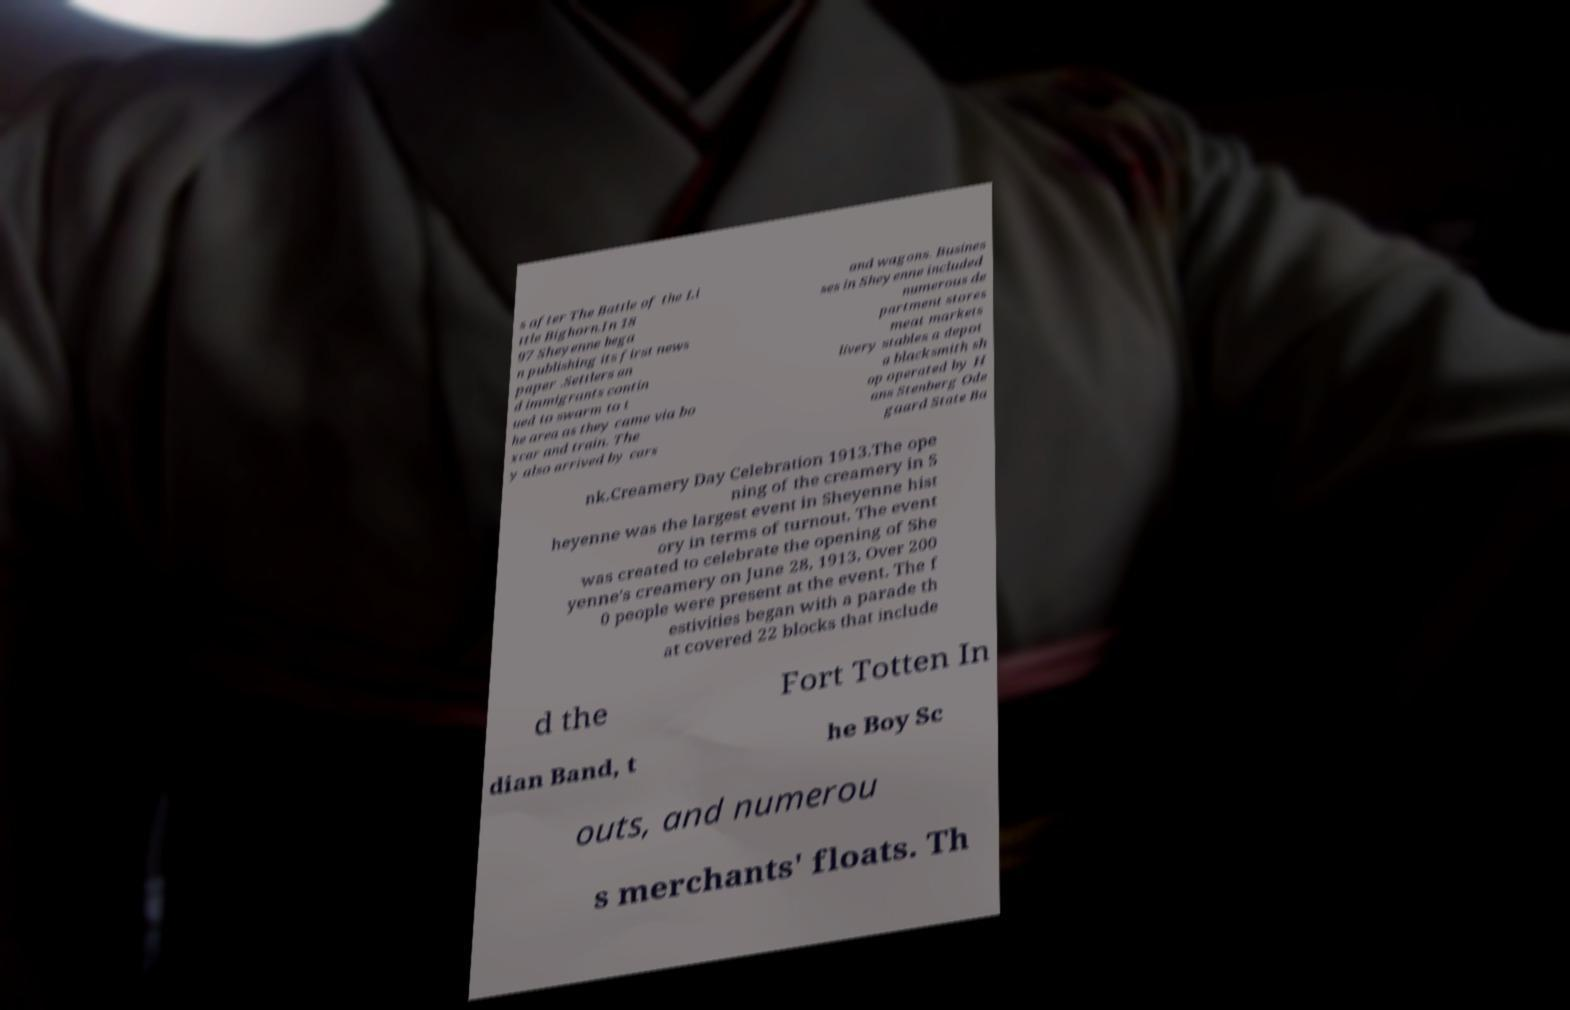Could you assist in decoding the text presented in this image and type it out clearly? s after The Battle of the Li ttle Bighorn.In 18 97 Sheyenne bega n publishing its first news paper .Settlers an d immigrants contin ued to swarm to t he area as they came via bo xcar and train. The y also arrived by cars and wagons. Busines ses in Sheyenne included numerous de partment stores meat markets livery stables a depot a blacksmith sh op operated by H ans Stenberg Ode gaard State Ba nk.Creamery Day Celebration 1913.The ope ning of the creamery in S heyenne was the largest event in Sheyenne hist ory in terms of turnout. The event was created to celebrate the opening of She yenne's creamery on June 28, 1913. Over 200 0 people were present at the event. The f estivities began with a parade th at covered 22 blocks that include d the Fort Totten In dian Band, t he Boy Sc outs, and numerou s merchants' floats. Th 